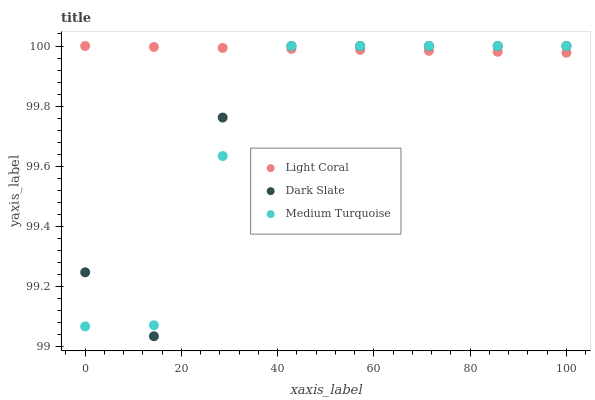Does Medium Turquoise have the minimum area under the curve?
Answer yes or no. Yes. Does Light Coral have the maximum area under the curve?
Answer yes or no. Yes. Does Dark Slate have the minimum area under the curve?
Answer yes or no. No. Does Dark Slate have the maximum area under the curve?
Answer yes or no. No. Is Light Coral the smoothest?
Answer yes or no. Yes. Is Dark Slate the roughest?
Answer yes or no. Yes. Is Medium Turquoise the smoothest?
Answer yes or no. No. Is Medium Turquoise the roughest?
Answer yes or no. No. Does Dark Slate have the lowest value?
Answer yes or no. Yes. Does Medium Turquoise have the lowest value?
Answer yes or no. No. Does Medium Turquoise have the highest value?
Answer yes or no. Yes. Does Light Coral intersect Dark Slate?
Answer yes or no. Yes. Is Light Coral less than Dark Slate?
Answer yes or no. No. Is Light Coral greater than Dark Slate?
Answer yes or no. No. 